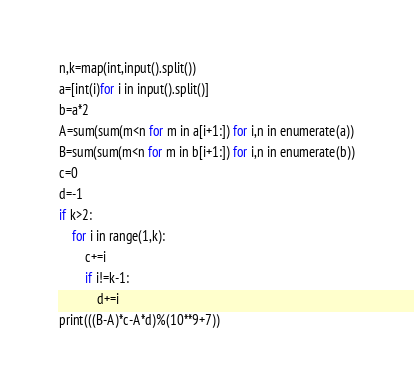Convert code to text. <code><loc_0><loc_0><loc_500><loc_500><_Python_>n,k=map(int,input().split())
a=[int(i)for i in input().split()]
b=a*2
A=sum(sum(m<n for m in a[i+1:]) for i,n in enumerate(a))
B=sum(sum(m<n for m in b[i+1:]) for i,n in enumerate(b))
c=0
d=-1
if k>2:
    for i in range(1,k):
        c+=i
        if i!=k-1:
            d+=i
print(((B-A)*c-A*d)%(10**9+7))</code> 